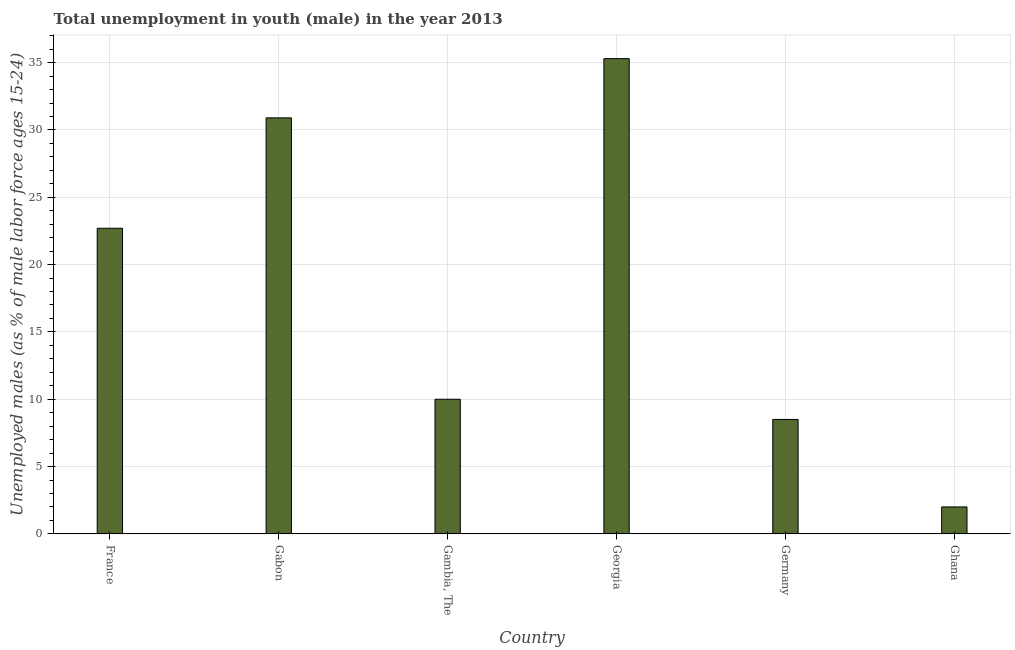What is the title of the graph?
Your response must be concise. Total unemployment in youth (male) in the year 2013. What is the label or title of the X-axis?
Your answer should be very brief. Country. What is the label or title of the Y-axis?
Your answer should be compact. Unemployed males (as % of male labor force ages 15-24). Across all countries, what is the maximum unemployed male youth population?
Give a very brief answer. 35.3. In which country was the unemployed male youth population maximum?
Make the answer very short. Georgia. What is the sum of the unemployed male youth population?
Your answer should be compact. 109.4. What is the difference between the unemployed male youth population in Gambia, The and Georgia?
Ensure brevity in your answer.  -25.3. What is the average unemployed male youth population per country?
Your answer should be compact. 18.23. What is the median unemployed male youth population?
Provide a short and direct response. 16.35. In how many countries, is the unemployed male youth population greater than 33 %?
Provide a succinct answer. 1. What is the ratio of the unemployed male youth population in Germany to that in Ghana?
Provide a succinct answer. 4.25. Is the difference between the unemployed male youth population in Georgia and Germany greater than the difference between any two countries?
Provide a short and direct response. No. Is the sum of the unemployed male youth population in France and Gabon greater than the maximum unemployed male youth population across all countries?
Your answer should be very brief. Yes. What is the difference between the highest and the lowest unemployed male youth population?
Make the answer very short. 33.3. In how many countries, is the unemployed male youth population greater than the average unemployed male youth population taken over all countries?
Your answer should be very brief. 3. What is the Unemployed males (as % of male labor force ages 15-24) in France?
Your response must be concise. 22.7. What is the Unemployed males (as % of male labor force ages 15-24) of Gabon?
Offer a terse response. 30.9. What is the Unemployed males (as % of male labor force ages 15-24) in Georgia?
Your answer should be very brief. 35.3. What is the Unemployed males (as % of male labor force ages 15-24) of Germany?
Give a very brief answer. 8.5. What is the Unemployed males (as % of male labor force ages 15-24) of Ghana?
Your response must be concise. 2. What is the difference between the Unemployed males (as % of male labor force ages 15-24) in France and Gambia, The?
Provide a short and direct response. 12.7. What is the difference between the Unemployed males (as % of male labor force ages 15-24) in France and Ghana?
Ensure brevity in your answer.  20.7. What is the difference between the Unemployed males (as % of male labor force ages 15-24) in Gabon and Gambia, The?
Your response must be concise. 20.9. What is the difference between the Unemployed males (as % of male labor force ages 15-24) in Gabon and Germany?
Your answer should be compact. 22.4. What is the difference between the Unemployed males (as % of male labor force ages 15-24) in Gabon and Ghana?
Make the answer very short. 28.9. What is the difference between the Unemployed males (as % of male labor force ages 15-24) in Gambia, The and Georgia?
Keep it short and to the point. -25.3. What is the difference between the Unemployed males (as % of male labor force ages 15-24) in Georgia and Germany?
Make the answer very short. 26.8. What is the difference between the Unemployed males (as % of male labor force ages 15-24) in Georgia and Ghana?
Your answer should be compact. 33.3. What is the difference between the Unemployed males (as % of male labor force ages 15-24) in Germany and Ghana?
Your response must be concise. 6.5. What is the ratio of the Unemployed males (as % of male labor force ages 15-24) in France to that in Gabon?
Ensure brevity in your answer.  0.73. What is the ratio of the Unemployed males (as % of male labor force ages 15-24) in France to that in Gambia, The?
Your response must be concise. 2.27. What is the ratio of the Unemployed males (as % of male labor force ages 15-24) in France to that in Georgia?
Provide a short and direct response. 0.64. What is the ratio of the Unemployed males (as % of male labor force ages 15-24) in France to that in Germany?
Offer a very short reply. 2.67. What is the ratio of the Unemployed males (as % of male labor force ages 15-24) in France to that in Ghana?
Your answer should be compact. 11.35. What is the ratio of the Unemployed males (as % of male labor force ages 15-24) in Gabon to that in Gambia, The?
Give a very brief answer. 3.09. What is the ratio of the Unemployed males (as % of male labor force ages 15-24) in Gabon to that in Germany?
Your answer should be very brief. 3.63. What is the ratio of the Unemployed males (as % of male labor force ages 15-24) in Gabon to that in Ghana?
Keep it short and to the point. 15.45. What is the ratio of the Unemployed males (as % of male labor force ages 15-24) in Gambia, The to that in Georgia?
Give a very brief answer. 0.28. What is the ratio of the Unemployed males (as % of male labor force ages 15-24) in Gambia, The to that in Germany?
Give a very brief answer. 1.18. What is the ratio of the Unemployed males (as % of male labor force ages 15-24) in Georgia to that in Germany?
Provide a short and direct response. 4.15. What is the ratio of the Unemployed males (as % of male labor force ages 15-24) in Georgia to that in Ghana?
Give a very brief answer. 17.65. What is the ratio of the Unemployed males (as % of male labor force ages 15-24) in Germany to that in Ghana?
Make the answer very short. 4.25. 